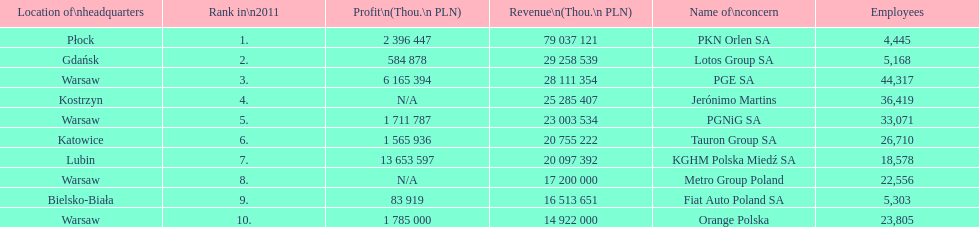What is the difference in employees for rank 1 and rank 3? 39,872 employees. 